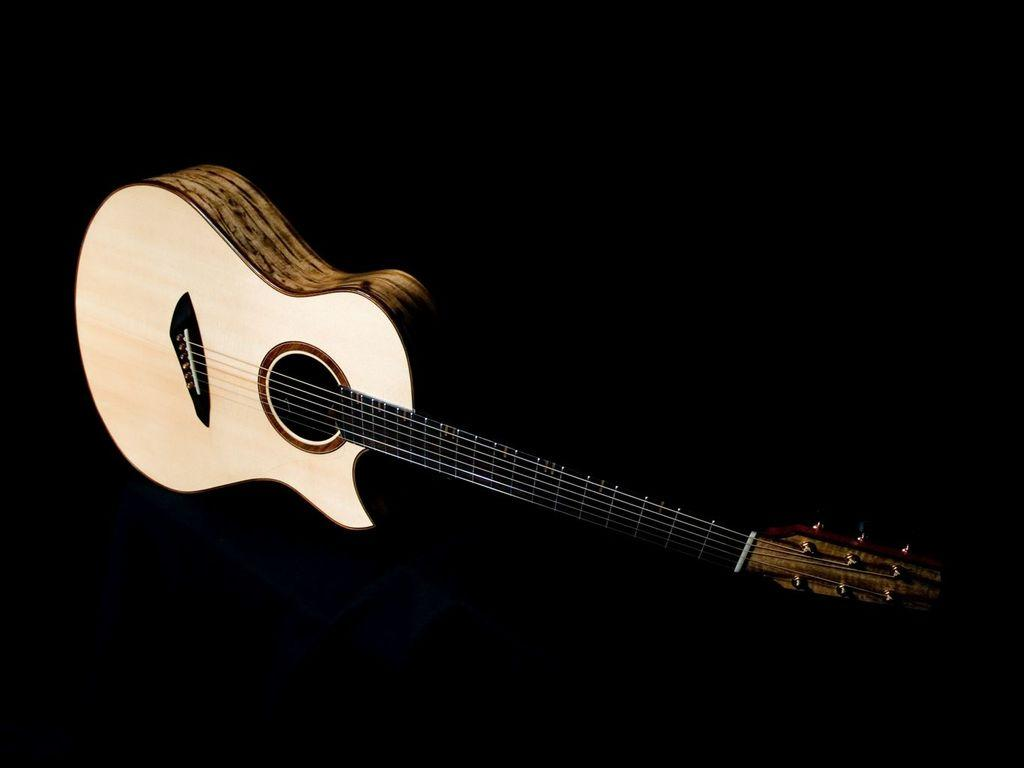What musical instrument is present in the image? The image contains a guitar. What feature of the guitar is mentioned in the facts? The guitar has strings. What color is the background of the image? The background of the image is black. What type of unit is being measured by the popcorn in the image? There is no popcorn present in the image, so it is not possible to determine what type of unit is being measured. 